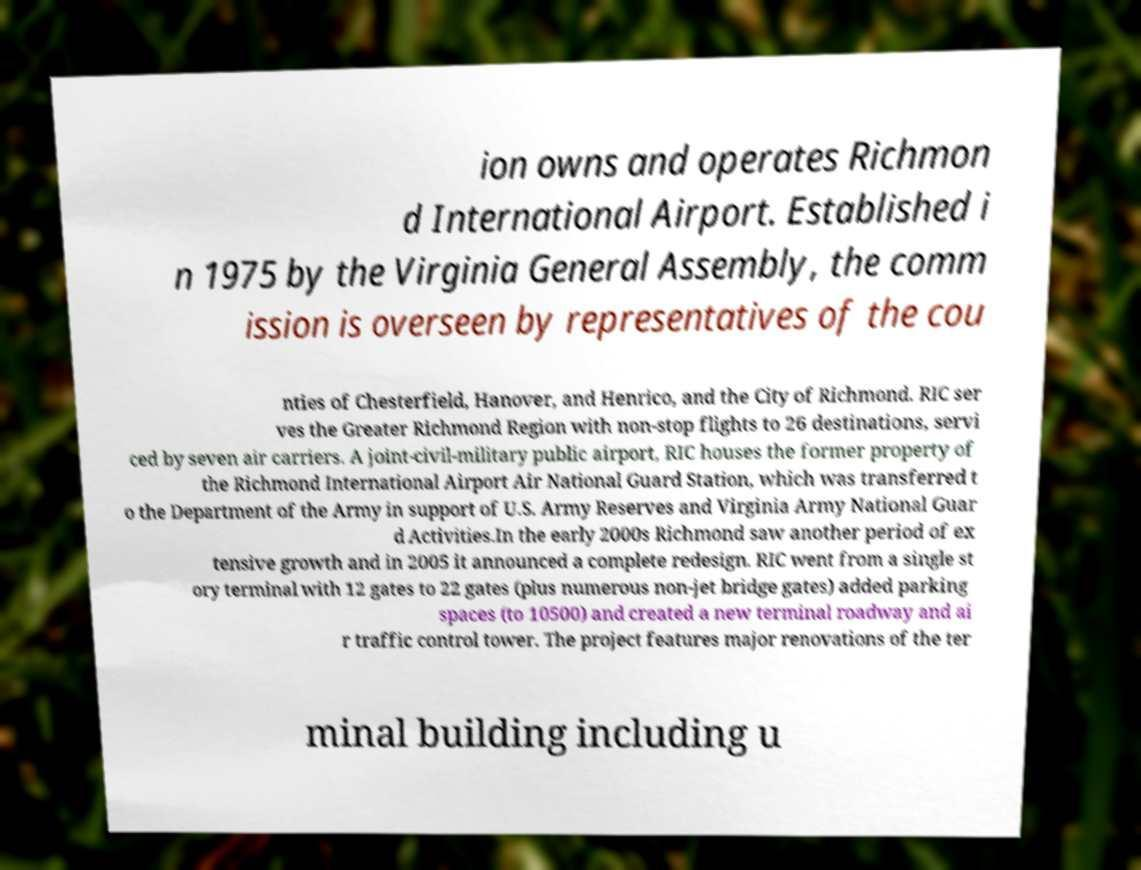What messages or text are displayed in this image? I need them in a readable, typed format. ion owns and operates Richmon d International Airport. Established i n 1975 by the Virginia General Assembly, the comm ission is overseen by representatives of the cou nties of Chesterfield, Hanover, and Henrico, and the City of Richmond. RIC ser ves the Greater Richmond Region with non-stop flights to 26 destinations, servi ced by seven air carriers. A joint-civil-military public airport, RIC houses the former property of the Richmond International Airport Air National Guard Station, which was transferred t o the Department of the Army in support of U.S. Army Reserves and Virginia Army National Guar d Activities.In the early 2000s Richmond saw another period of ex tensive growth and in 2005 it announced a complete redesign. RIC went from a single st ory terminal with 12 gates to 22 gates (plus numerous non-jet bridge gates) added parking spaces (to 10500) and created a new terminal roadway and ai r traffic control tower. The project features major renovations of the ter minal building including u 